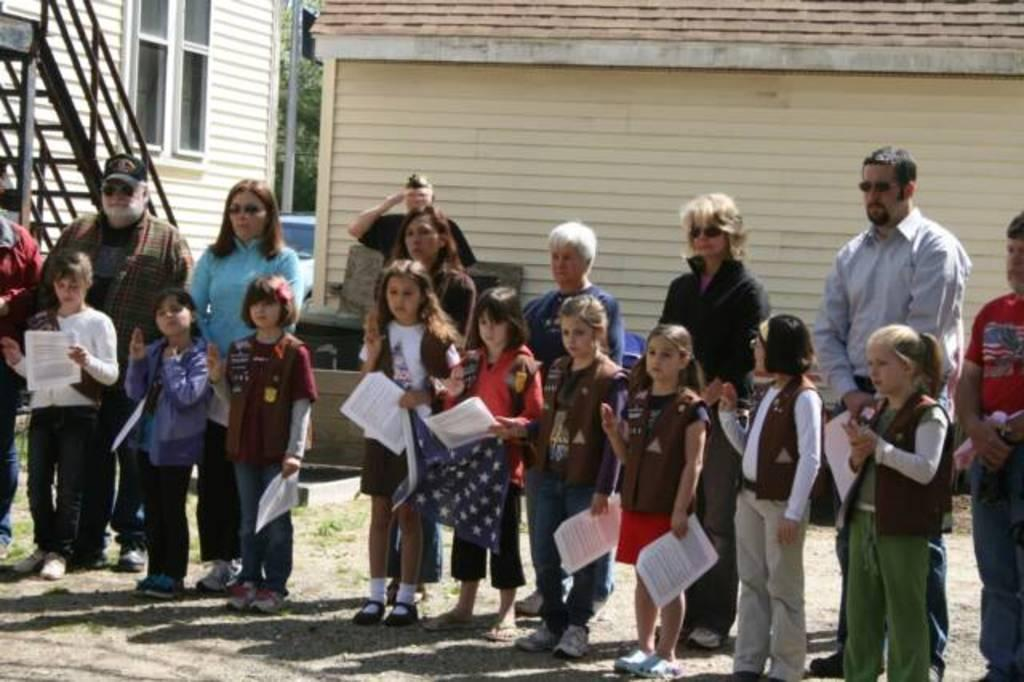What are the people in the image doing? The people in the image are standing. What are some of the people holding in their hands? Some of the people are holding papers in their hands. What can be seen in the background of the image? There is a building and trees in the background of the image. How many beds are visible in the image? There are no beds visible in the image. 